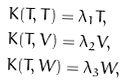Convert formula to latex. <formula><loc_0><loc_0><loc_500><loc_500>& K ( T , T ) = \lambda _ { 1 } T , \\ & K ( T , V ) = \lambda _ { 2 } V , \\ & K ( T , W ) = \lambda _ { 3 } W ,</formula> 